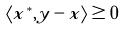Convert formula to latex. <formula><loc_0><loc_0><loc_500><loc_500>\langle x ^ { * } , y - x \rangle \geq 0</formula> 